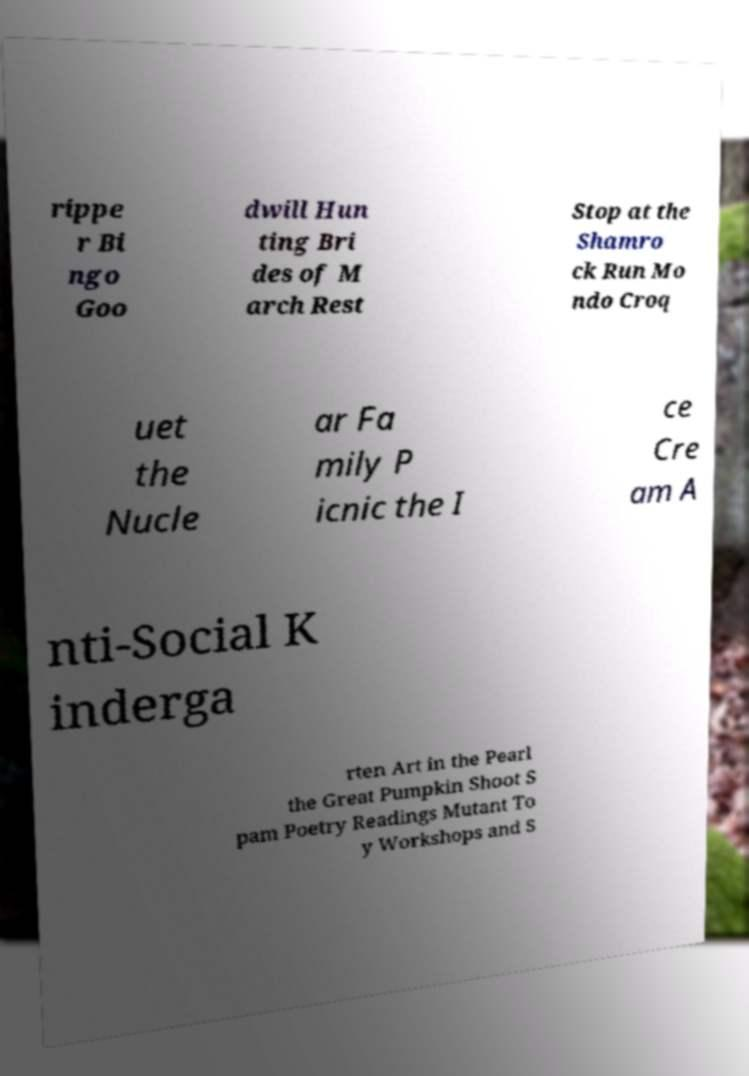For documentation purposes, I need the text within this image transcribed. Could you provide that? rippe r Bi ngo Goo dwill Hun ting Bri des of M arch Rest Stop at the Shamro ck Run Mo ndo Croq uet the Nucle ar Fa mily P icnic the I ce Cre am A nti-Social K inderga rten Art in the Pearl the Great Pumpkin Shoot S pam Poetry Readings Mutant To y Workshops and S 